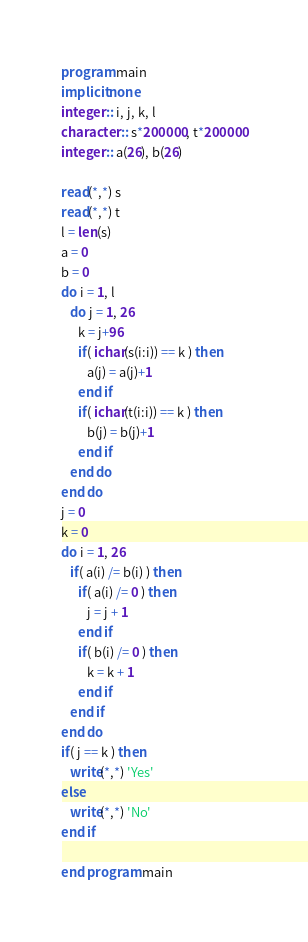<code> <loc_0><loc_0><loc_500><loc_500><_FORTRAN_>program main
implicit none
integer :: i, j, k, l
character :: s*200000, t*200000
integer :: a(26), b(26)

read(*,*) s
read(*,*) t
l = len(s)
a = 0
b = 0
do i = 1, l
   do j = 1, 26
      k = j+96
      if( ichar(s(i:i)) == k ) then
         a(j) = a(j)+1
      end if
      if( ichar(t(i:i)) == k ) then
         b(j) = b(j)+1
      end if
   end do
end do
j = 0
k = 0
do i = 1, 26
   if( a(i) /= b(i) ) then
      if( a(i) /= 0 ) then
         j = j + 1
      end if
      if( b(i) /= 0 ) then
         k = k + 1
      end if
   end if
end do
if( j == k ) then
   write(*,*) 'Yes'
else
   write(*,*) 'No'
end if

end program main
</code> 